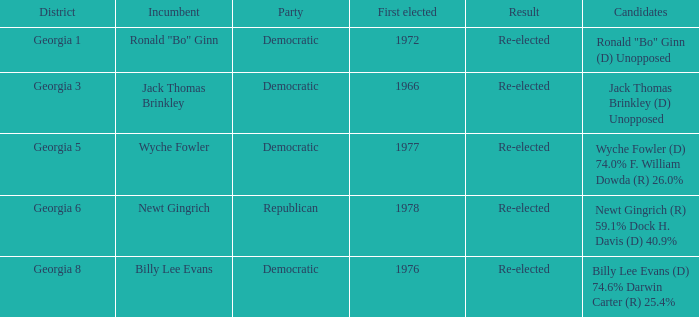What is the party with the candidates newt gingrich (r) 59.1% dock h. davis (d) 40.9%? Republican. 